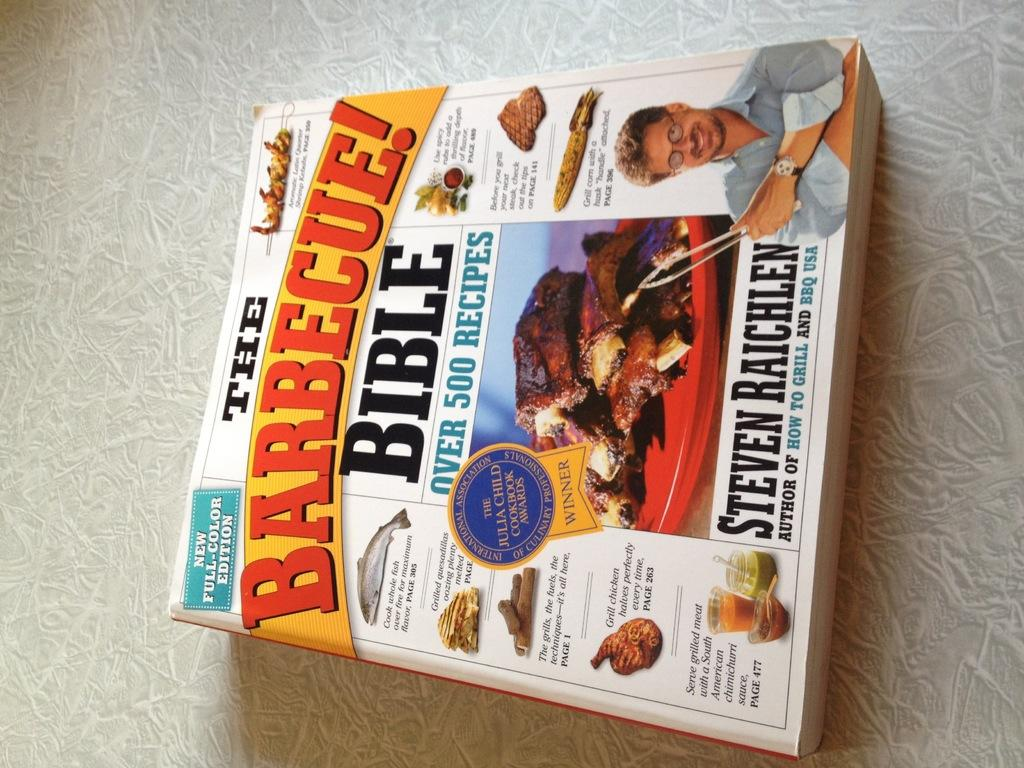<image>
Provide a brief description of the given image. The Barbecue Bible book is sat on the counter. 